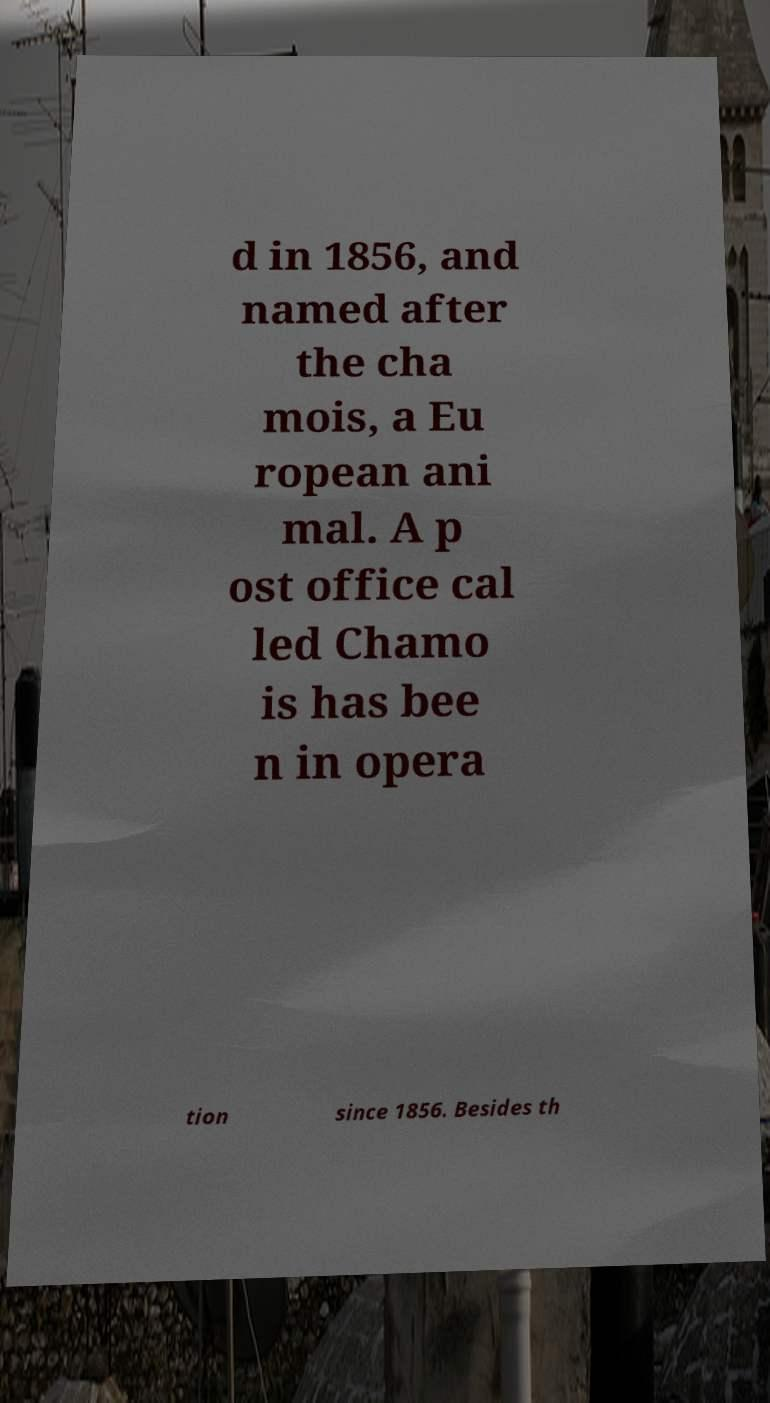Can you read and provide the text displayed in the image?This photo seems to have some interesting text. Can you extract and type it out for me? d in 1856, and named after the cha mois, a Eu ropean ani mal. A p ost office cal led Chamo is has bee n in opera tion since 1856. Besides th 